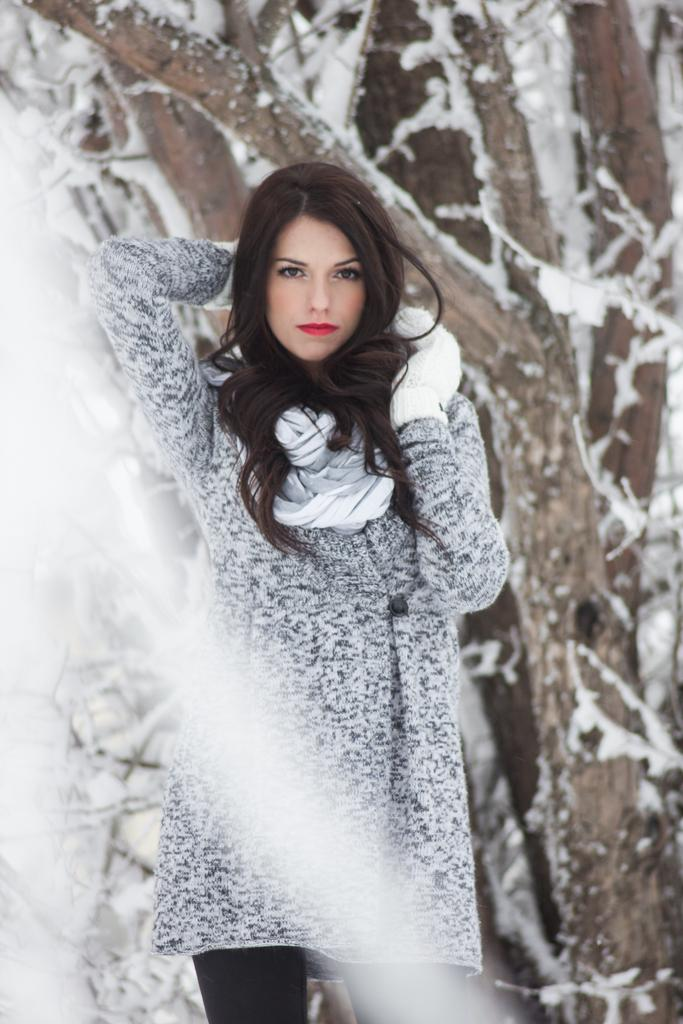What is the main subject in the image? There is a woman standing in the image. What can be seen behind the woman? Trees are visible at the back of the woman. What type of weather condition is depicted in the image? Snow is present in the image. What type of knot is the woman using to hold her scarf in the image? There is no knot visible in the image, as the woman is not wearing a scarf. What type of writing instrument is the woman holding in the image? There is no writing instrument present in the image. 